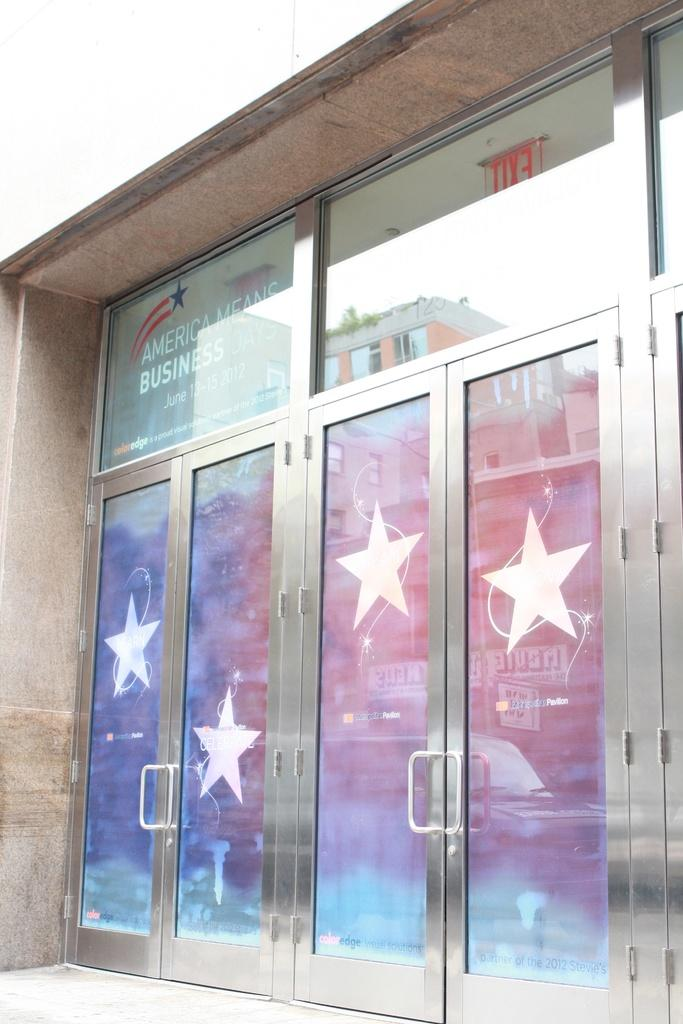What type of doors are depicted in the image? The doors in the image have stars on them. What feature do the doors have? The doors have handles. What can be seen through the glass in the image? Buildings with windows and the sky are visible through the glass. What is the purpose of the glass with text in the image? The glass with text may serve as a sign or label. What is the name board used for in the image? The name board is likely used to display a name or title. How many horses are visible in the image? There are no horses present in the image. What type of learning is taking place in the image? There is no learning activity depicted in the image. 